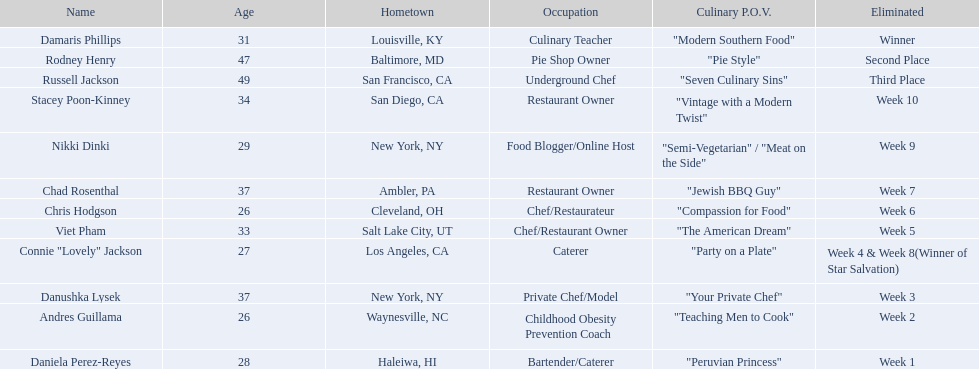Who are the participants in the competition? Damaris Phillips, Rodney Henry, Russell Jackson, Stacey Poon-Kinney, Nikki Dinki, Chad Rosenthal, Chris Hodgson, Viet Pham, Connie "Lovely" Jackson, Danushka Lysek, Andres Guillama, Daniela Perez-Reyes. Whose culinary approach is more comprehensive than a blend of classic and contemporary styles? "Semi-Vegetarian" / "Meat on the Side". Which contestant focuses on a semi-vegetarian or side-meat point of view? Nikki Dinki. 